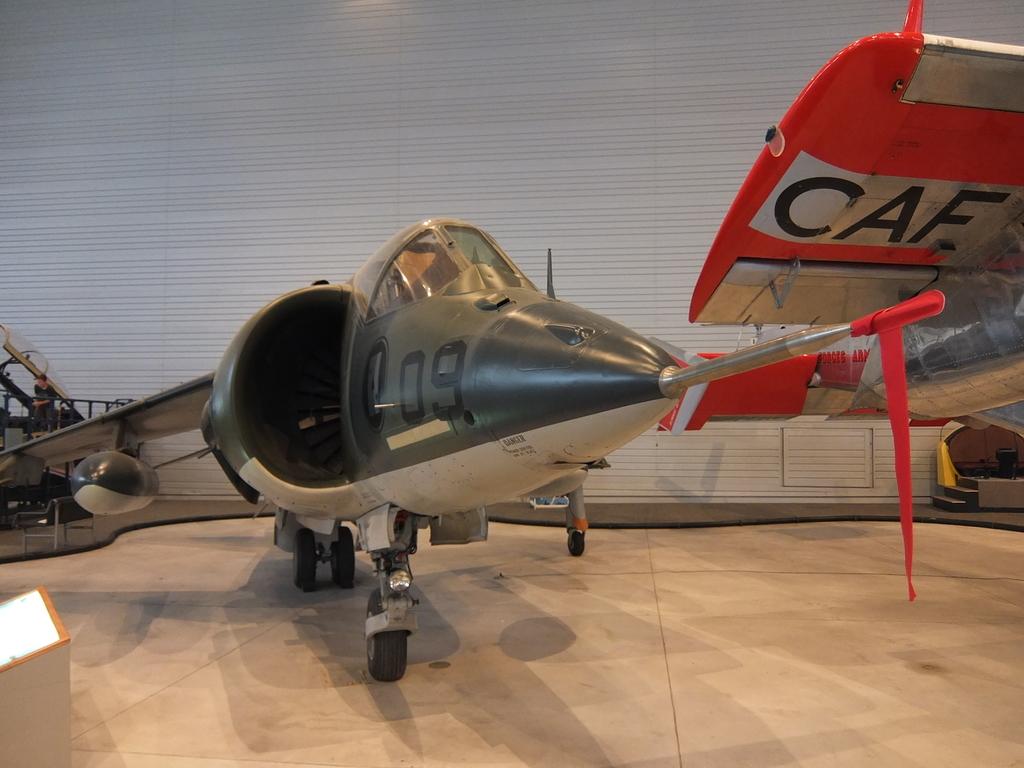What number is written on the nose of this plane?
Give a very brief answer. 09. 